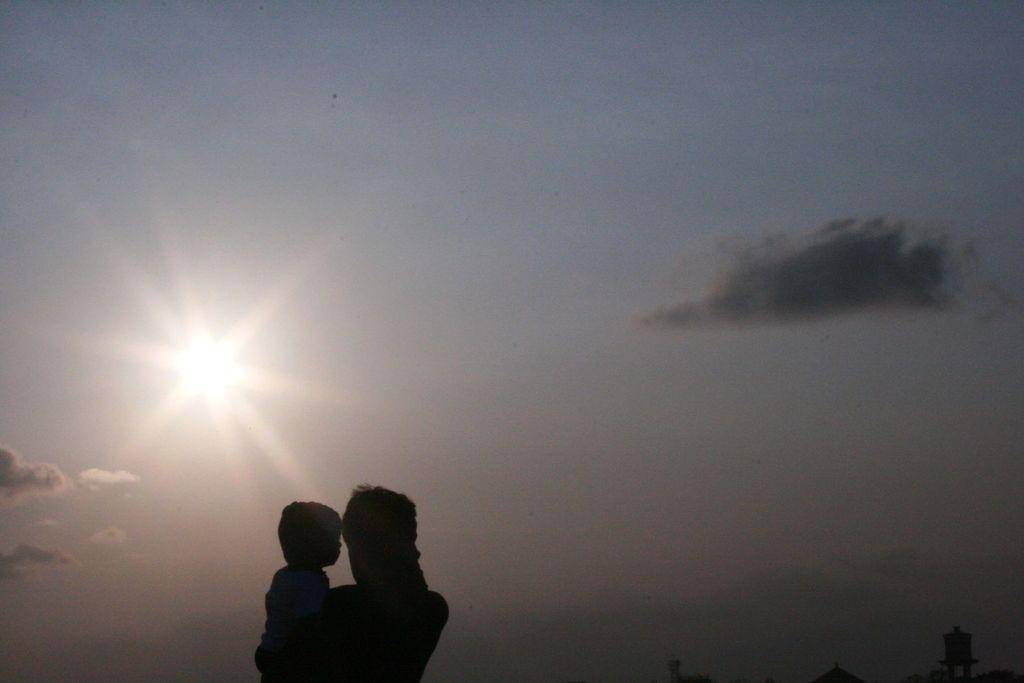How many people are in the image? There are two persons in the image. What can be seen in the sky in the background of the image? The sun is visible in the sky in the background of the image. What type of structures are present at the bottom of the image? There are objects that look like buildings at the bottom of the image. What type of square stamp can be seen on the forehead of one of the persons in the image? There is no square stamp visible on the forehead of any person in the image. Are there any giants present in the image? There are no giants present in the image; it features two regular-sized persons. 